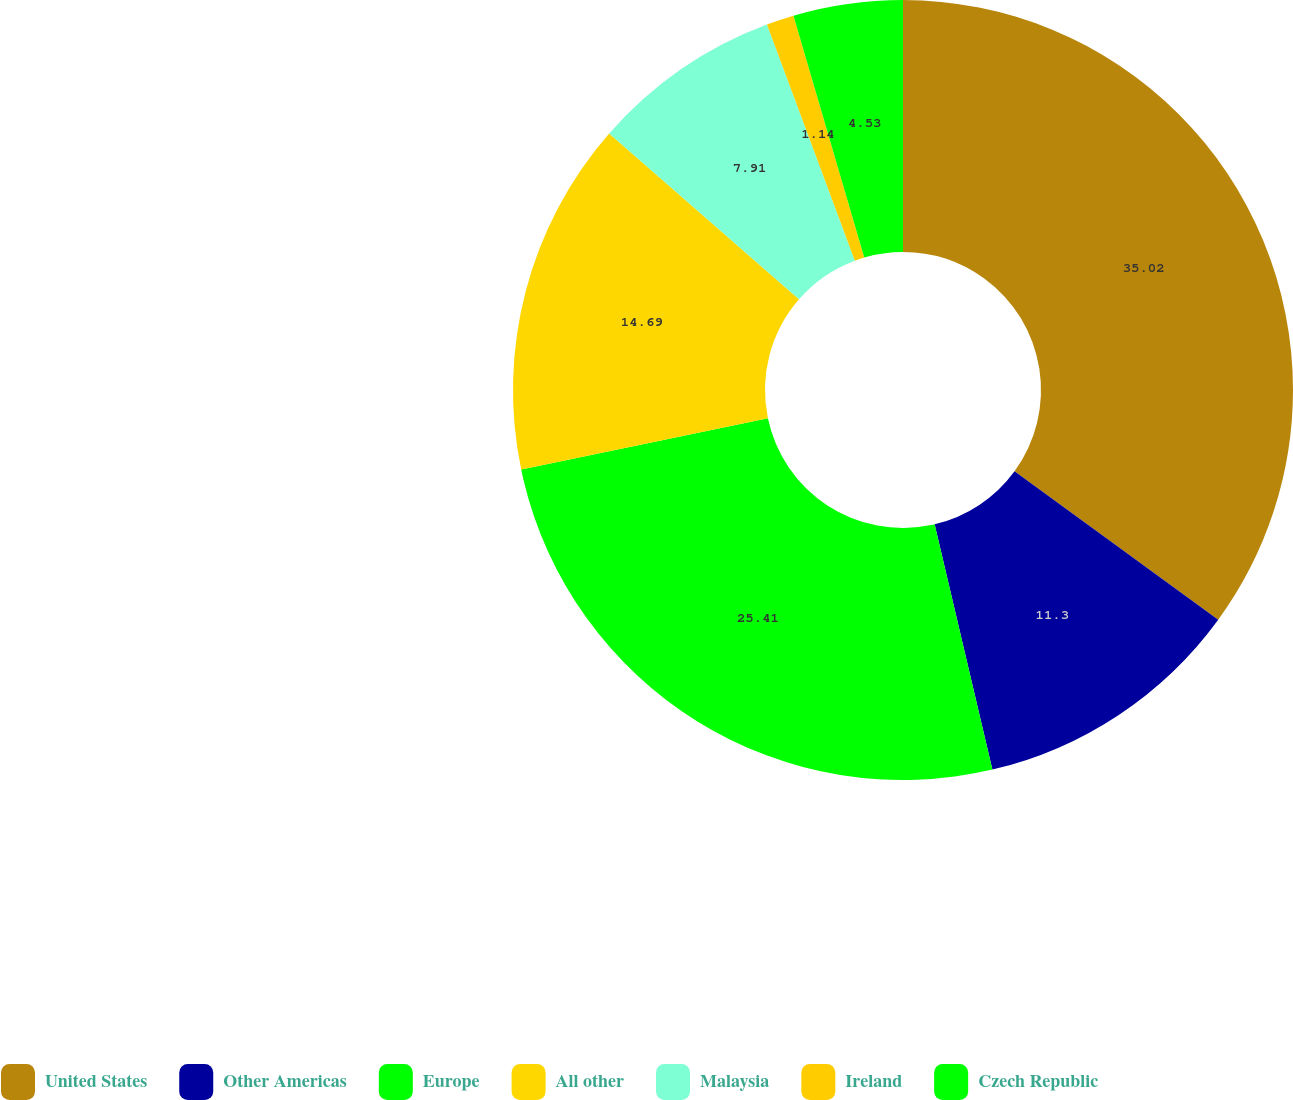Convert chart to OTSL. <chart><loc_0><loc_0><loc_500><loc_500><pie_chart><fcel>United States<fcel>Other Americas<fcel>Europe<fcel>All other<fcel>Malaysia<fcel>Ireland<fcel>Czech Republic<nl><fcel>35.02%<fcel>11.3%<fcel>25.41%<fcel>14.69%<fcel>7.91%<fcel>1.14%<fcel>4.53%<nl></chart> 